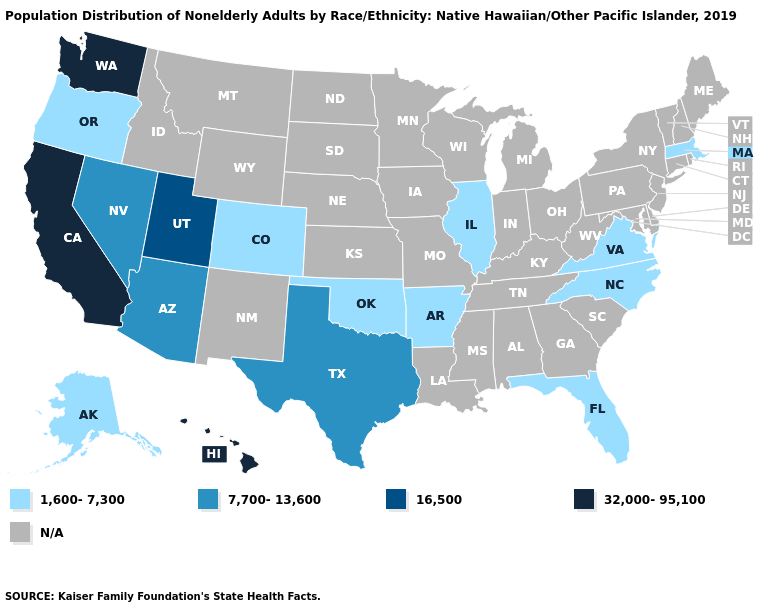What is the value of Mississippi?
Concise answer only. N/A. Name the states that have a value in the range 16,500?
Keep it brief. Utah. What is the value of Iowa?
Write a very short answer. N/A. Among the states that border West Virginia , which have the highest value?
Give a very brief answer. Virginia. Which states have the lowest value in the USA?
Be succinct. Alaska, Arkansas, Colorado, Florida, Illinois, Massachusetts, North Carolina, Oklahoma, Oregon, Virginia. What is the value of North Dakota?
Give a very brief answer. N/A. How many symbols are there in the legend?
Quick response, please. 5. Does Virginia have the lowest value in the USA?
Concise answer only. Yes. Name the states that have a value in the range N/A?
Keep it brief. Alabama, Connecticut, Delaware, Georgia, Idaho, Indiana, Iowa, Kansas, Kentucky, Louisiana, Maine, Maryland, Michigan, Minnesota, Mississippi, Missouri, Montana, Nebraska, New Hampshire, New Jersey, New Mexico, New York, North Dakota, Ohio, Pennsylvania, Rhode Island, South Carolina, South Dakota, Tennessee, Vermont, West Virginia, Wisconsin, Wyoming. What is the highest value in the Northeast ?
Quick response, please. 1,600-7,300. 